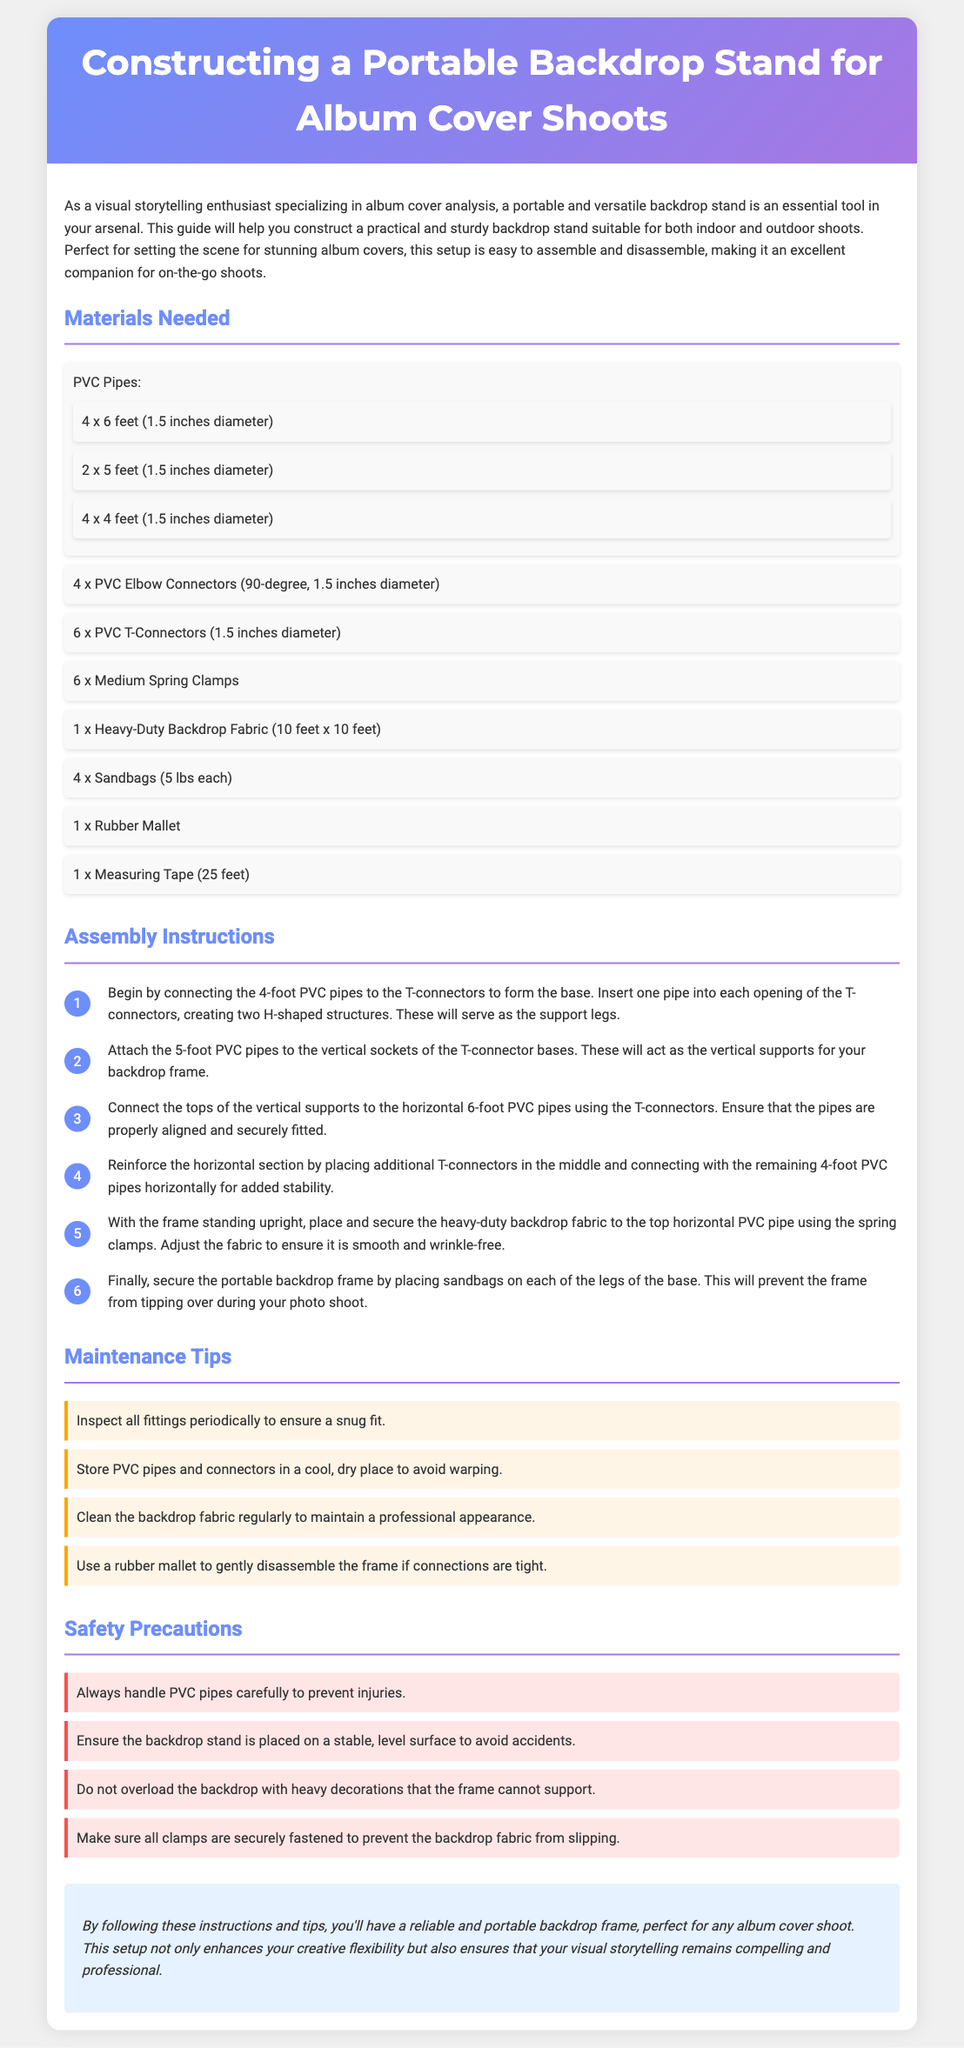What are the dimensions of the heavy-duty backdrop fabric? The dimensions of the heavy-duty backdrop fabric specified in the document are 10 feet x 10 feet.
Answer: 10 feet x 10 feet How many PVC T-connectors are needed? The document states that 6 PVC T-connectors are required for the assembly of the backdrop stand.
Answer: 6 What tool is recommended to help disassemble tight connections? The document suggests using a rubber mallet to gently disassemble the frame if connections are tight.
Answer: Rubber mallet What type of surface should the backdrop stand be placed on? The safety precautions recommend placing the backdrop stand on a stable, level surface to avoid accidents.
Answer: Stable, level surface How many sandbags are suggested for securing the backdrop frame? The document mentions placing 4 sandbags (5 lbs each) on the legs of the base for stability.
Answer: 4 Why is it important to clean the backdrop fabric regularly? Regular cleaning of the backdrop fabric is advised to maintain a professional appearance for better visual storytelling.
Answer: Professional appearance What shape are the support legs formed into with the PVC pipes? The support legs created with the PVC pipes form two H-shaped structures as described in the instructions.
Answer: H-shaped structures How many medium spring clamps are required? The document indicates that 6 medium spring clamps are needed to secure the backdrop fabric.
Answer: 6 